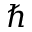<formula> <loc_0><loc_0><loc_500><loc_500>\hbar</formula> 